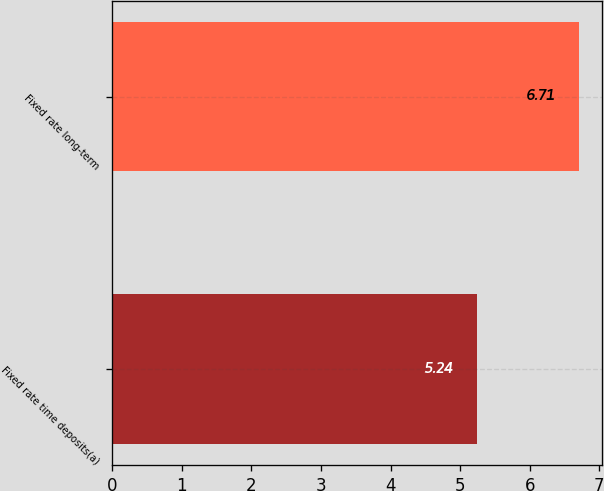<chart> <loc_0><loc_0><loc_500><loc_500><bar_chart><fcel>Fixed rate time deposits(a)<fcel>Fixed rate long-term<nl><fcel>5.24<fcel>6.71<nl></chart> 